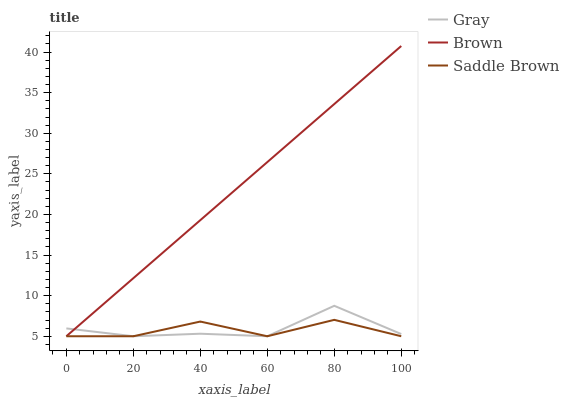Does Saddle Brown have the minimum area under the curve?
Answer yes or no. Yes. Does Brown have the maximum area under the curve?
Answer yes or no. Yes. Does Brown have the minimum area under the curve?
Answer yes or no. No. Does Saddle Brown have the maximum area under the curve?
Answer yes or no. No. Is Brown the smoothest?
Answer yes or no. Yes. Is Saddle Brown the roughest?
Answer yes or no. Yes. Is Saddle Brown the smoothest?
Answer yes or no. No. Is Brown the roughest?
Answer yes or no. No. Does Gray have the lowest value?
Answer yes or no. Yes. Does Brown have the highest value?
Answer yes or no. Yes. Does Saddle Brown have the highest value?
Answer yes or no. No. Does Saddle Brown intersect Gray?
Answer yes or no. Yes. Is Saddle Brown less than Gray?
Answer yes or no. No. Is Saddle Brown greater than Gray?
Answer yes or no. No. 